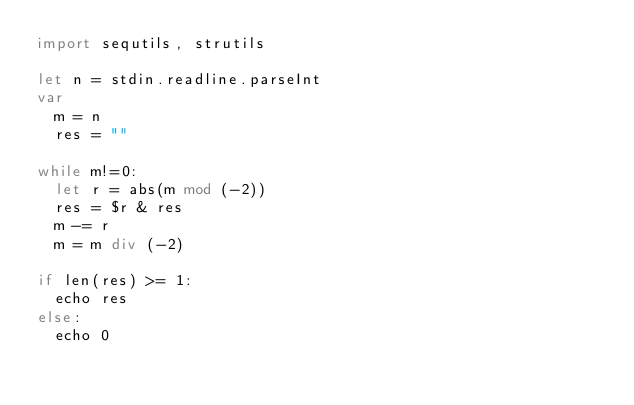Convert code to text. <code><loc_0><loc_0><loc_500><loc_500><_Nim_>import sequtils, strutils

let n = stdin.readline.parseInt
var
  m = n
  res = ""

while m!=0:
  let r = abs(m mod (-2))
  res = $r & res
  m -= r
  m = m div (-2)

if len(res) >= 1:
  echo res
else:
  echo 0
</code> 